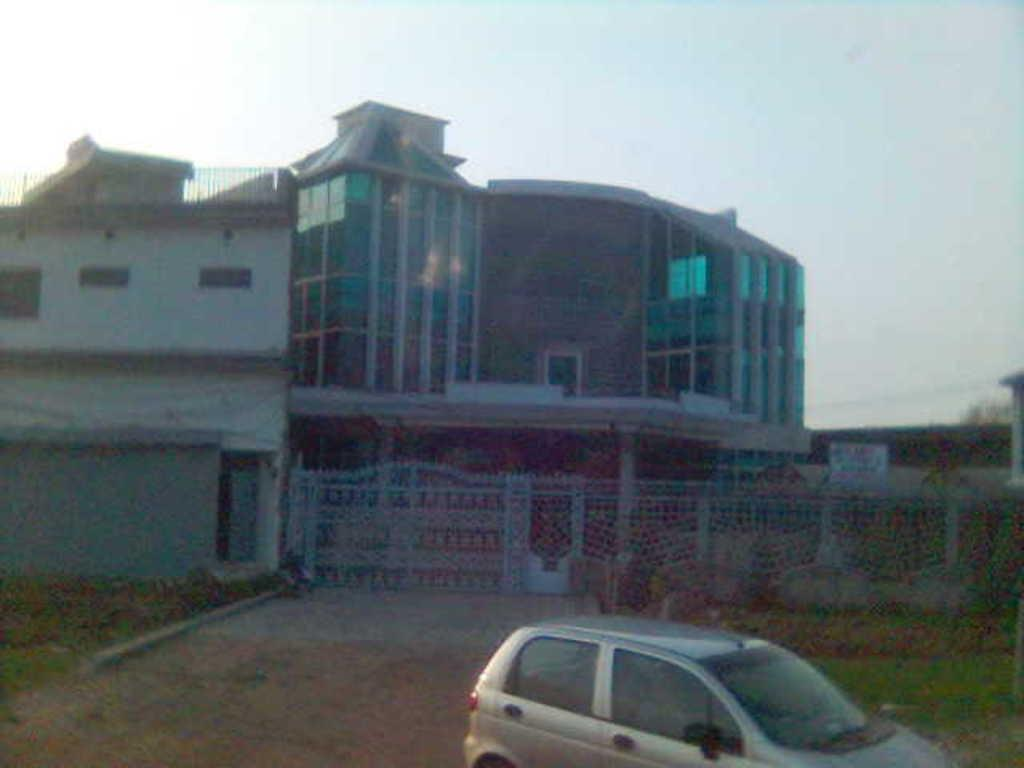What is the main subject in the middle of the image? There is a car in the middle of the image. What can be seen in the background of the image? There is a gate and a building in the background of the image. What is visible at the top of the image? The sky is visible at the top of the image. What type of terrain is at the bottom of the image? There is grass and land at the bottom of the image. How many wrens are sitting on the car in the image? There are no wrens present in the image. Is the car located inside a jail in the image? There is no indication of a jail in the image, and the car is not inside any enclosed structure. 